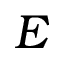Convert formula to latex. <formula><loc_0><loc_0><loc_500><loc_500>E</formula> 